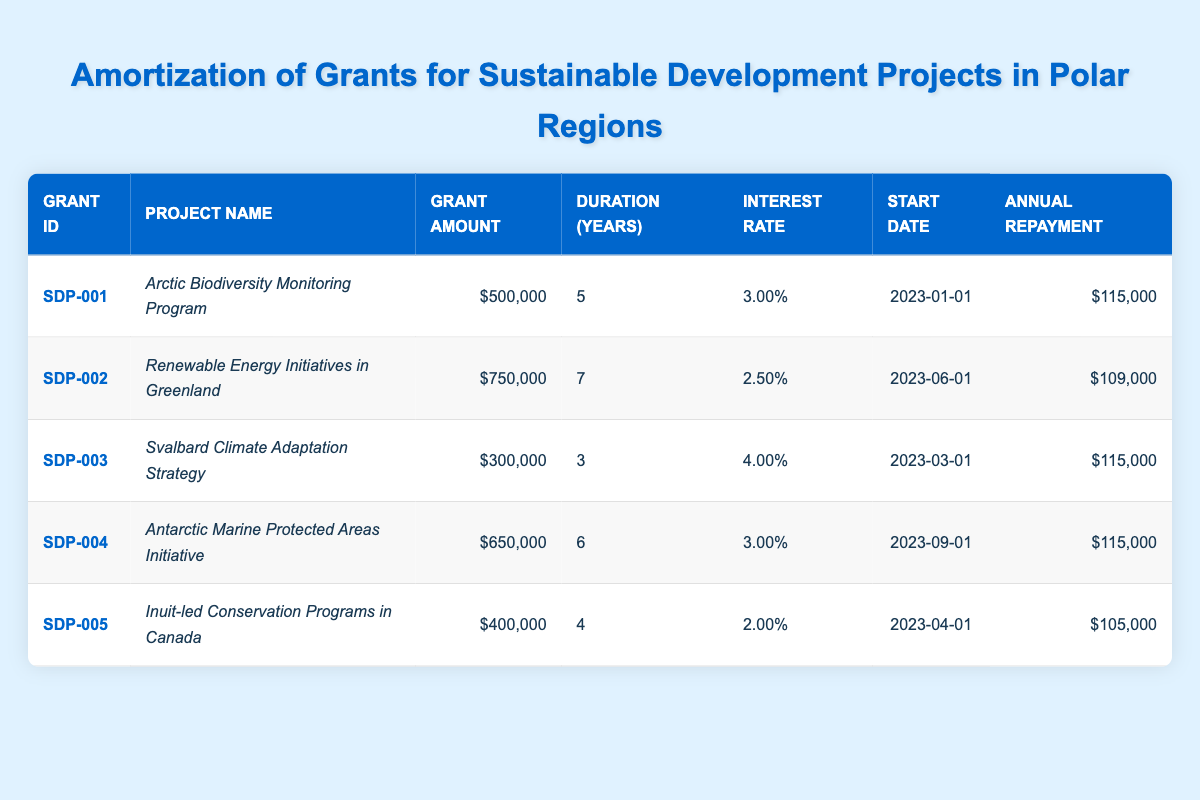What is the grant amount for the "Renewable Energy Initiatives in Greenland"? You can find the grant amount directly in the table under the "Grant Amount" column for this project. The row for "Renewable Energy Initiatives in Greenland" shows a grant amount of $750,000.
Answer: $750,000 How many years will the "Svalbard Climate Adaptation Strategy" last? The duration of the "Svalbard Climate Adaptation Strategy" is listed in the "Duration (Years)" column in the table. It indicates a duration of 3 years.
Answer: 3 years Which project has the highest annual repayment amount? By checking the "Annual Repayment" column for each project, we observe that the projects have repayment amounts of $115,000 (for SDP-001, SDP-003, and SDP-004) and $109,000 (for SDP-002) and $105,000 (for SDP-005). The highest amount listed is $115,000.
Answer: $115,000 What is the total grant amount for all projects combined? To find the total grant amount, we sum all the values in the "Grant Amount" column: $500,000 + $750,000 + $300,000 + $650,000 + $400,000 = $2,600,000.
Answer: $2,600,000 Is the interest rate for the "Inuit-led Conservation Programs in Canada" less than 3%? The interest rate for this project is 2%, which is less than 3%. This is directly observable in the "Interest Rate" column for the corresponding row.
Answer: Yes Which project has the shortest duration among all listed projects? Checking the "Duration (Years)" column, the "Svalbard Climate Adaptation Strategy" has a duration of 3 years, which is the shortest compared to others with 4, 5, 6, or 7 years.
Answer: 3 years If a project starts on "2023-06-01," when will it be completed based on its duration? The "Renewable Energy Initiatives in Greenland," which starts on "2023-06-01" with a duration of 7 years, will be completed after 7 years. Thus, the completion date is calculated by adding 7 years to the start date: 2023 + 7 = 2030. Therefore, it will be completed on "2023-06-01" + 7 years = "2030-06-01".
Answer: 2030-06-01 What percentage of the total grant amount does the "Antarctic Marine Protected Areas Initiative" represent? The grant amount for the "Antarctic Marine Protected Areas Initiative" is $650,000. To find the percentage it represents of the total grant amount ($2,600,000), we calculate (650,000 / 2,600,000) * 100 = approximately 25%.
Answer: 25% Which grant has an annual repayment amount lower than $110,000? Reviewing the "Annual Repayment" column, the "Inuit-led Conservation Programs in Canada" has an annual repayment of $105,000, which is below $110,000.
Answer: Yes 